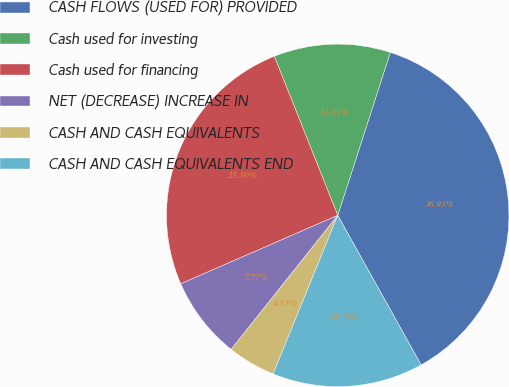Convert chart to OTSL. <chart><loc_0><loc_0><loc_500><loc_500><pie_chart><fcel>CASH FLOWS (USED FOR) PROVIDED<fcel>Cash used for investing<fcel>Cash used for financing<fcel>NET (DECREASE) INCREASE IN<fcel>CASH AND CASH EQUIVALENTS<fcel>CASH AND CASH EQUIVALENTS END<nl><fcel>36.93%<fcel>11.01%<fcel>25.5%<fcel>7.77%<fcel>4.53%<fcel>14.25%<nl></chart> 